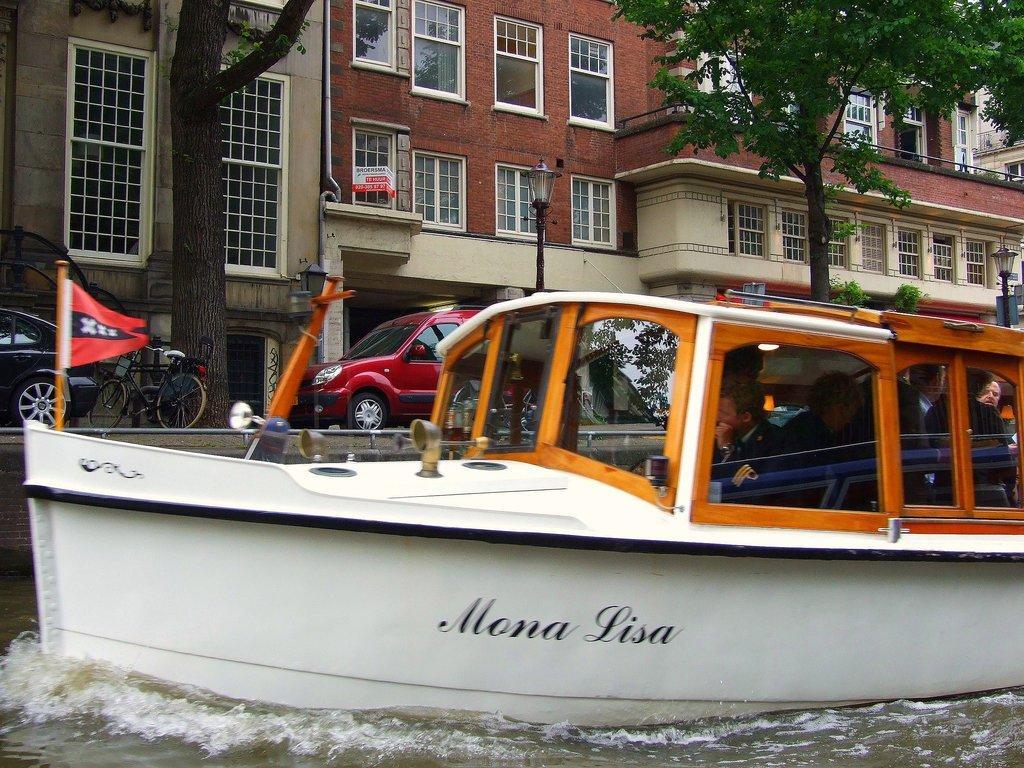Describe this image in one or two sentences. In this image we can see there is a boat floating in the water. In the background there is a building, in front of the building there are trees and few vehicles are parked. 